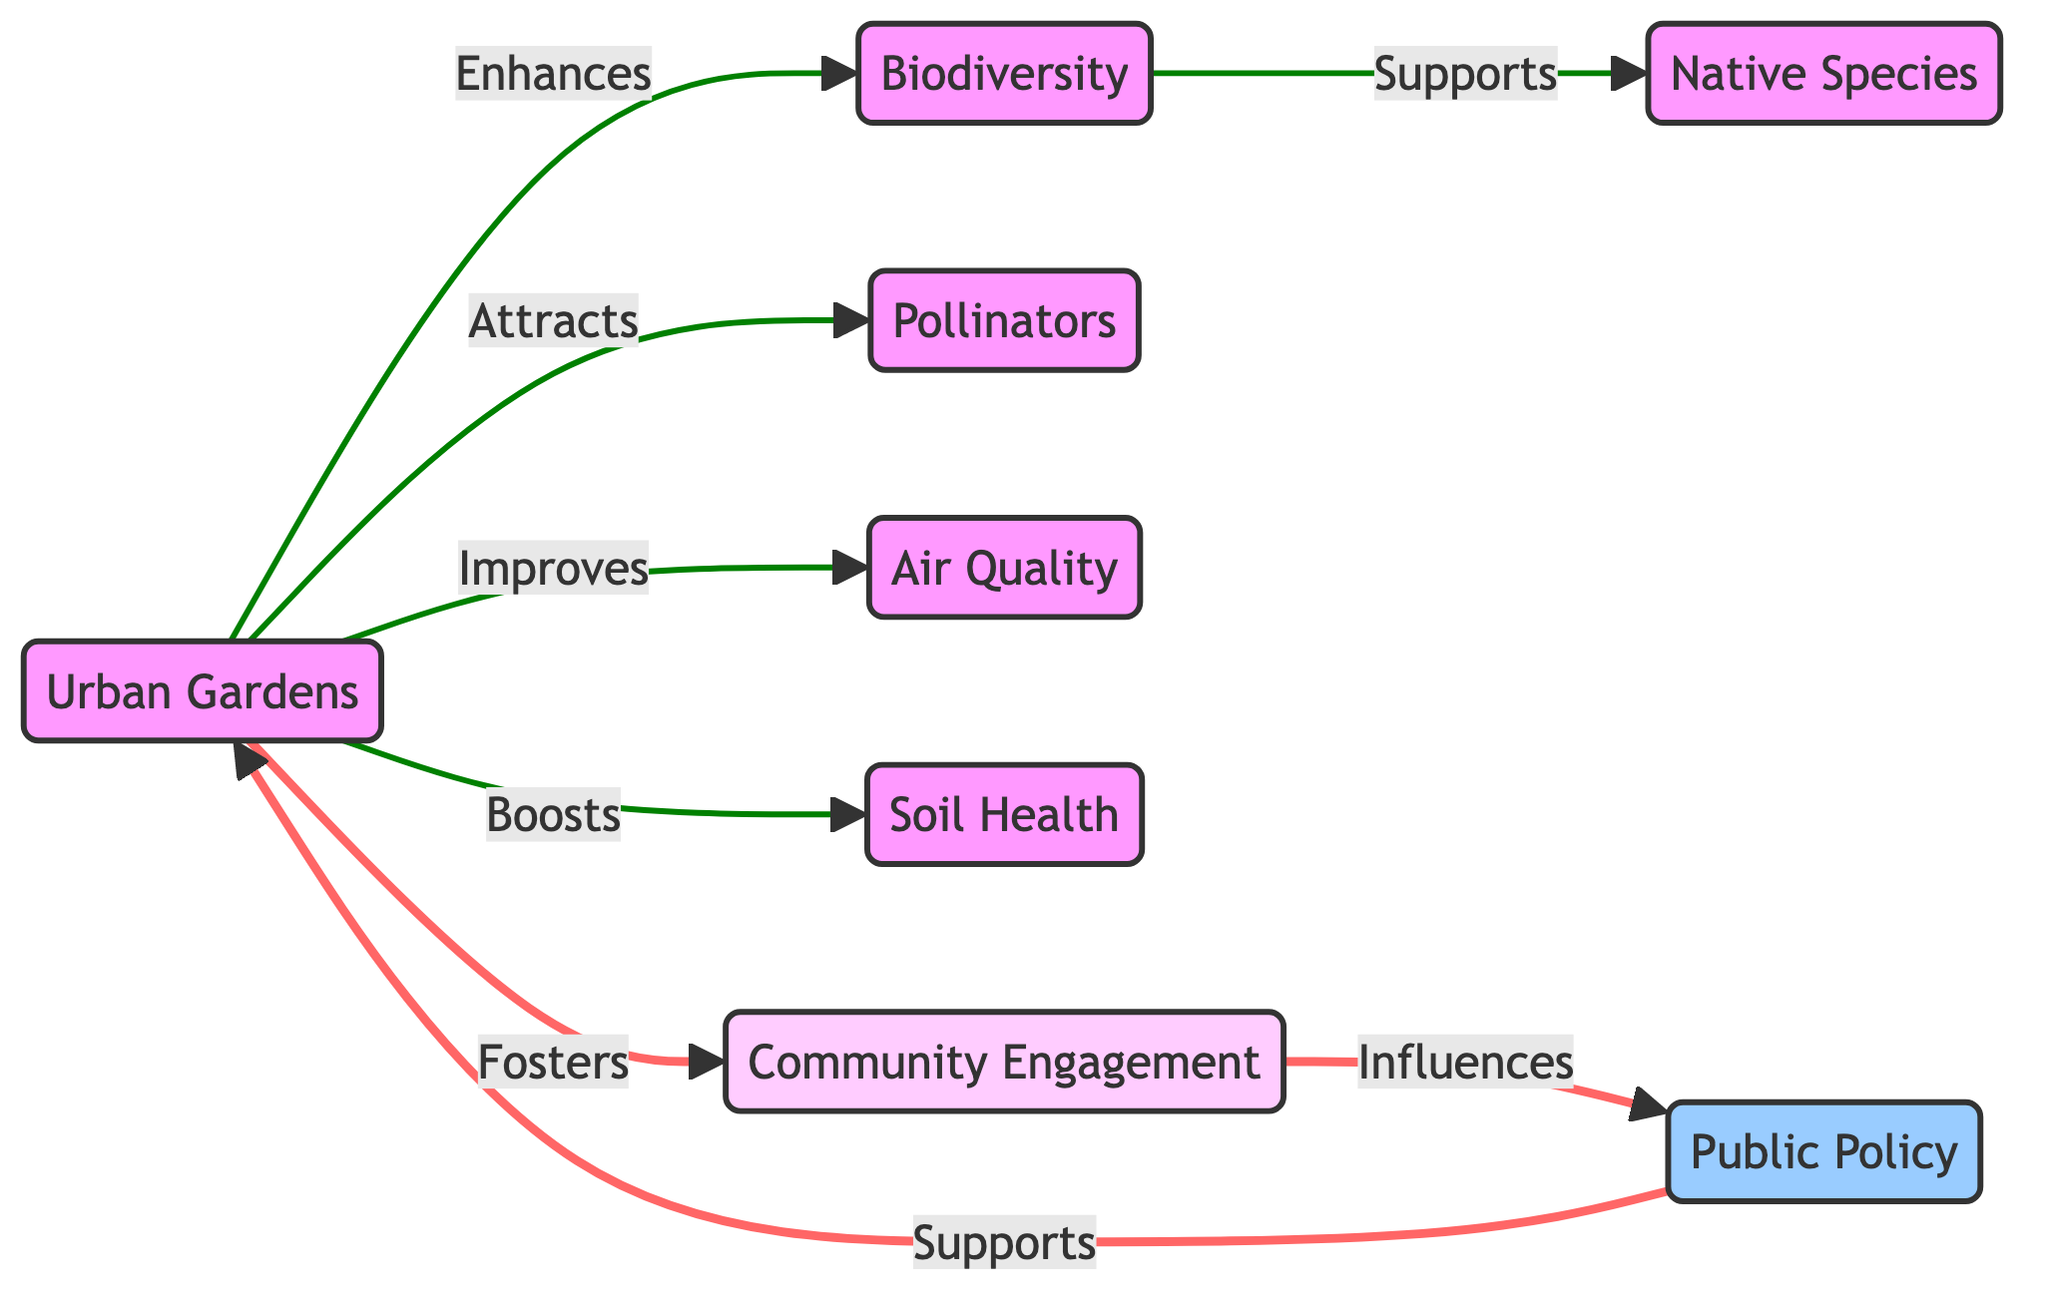What is the main contribution of urban gardens? Urban gardens enhance biodiversity, as directly stated in the diagram through the connection labeled "Enhances." This implies that urban gardens have a positive effect on the variety of life forms in the ecosystem.
Answer: Biodiversity How many direct benefits do urban gardens provide as indicated in the diagram? The diagram shows six direct benefits of urban gardens, with connections leading to biodiversity, pollinators, air quality, soil health, and community engagement. Each of these nodes represents a specific benefit.
Answer: Six What does biodiversity support according to the diagram? The diagram indicates that biodiversity supports native species, shown through the connection labeled "Supports." This means that a greater diversity of life contributes positively to the existence and proliferation of native species in urban gardens.
Answer: Native Species Which element influences public policy in the diagram? The diagram illustrates that community engagement influences public policy, as indicated by the connection labeled "Influences." This suggests that when communities are actively engaged in urban gardening, this involvement can impact the formulation of public policies regarding these spaces.
Answer: Community Engagement What does urban gardens improve that relates to environmental quality? The diagram states that urban gardens improve air quality, which is explicitly shown through the connection labeled "Improves." This demonstrates the role of urban gardens in enhancing the cleanliness and quality of air in urban ecosystems.
Answer: Air Quality Which element supports urban gardens as per the diagram’s connections? The diagram indicates that public policy supports urban gardens, as shown through the connection labeled "Supports." This means that favorable policies can create an environment conducive to the development and maintenance of urban gardens.
Answer: Public Policy What role do urban gardens play in attracting specific species? Urban gardens attract pollinators, as noted in the diagram under the connection labeled "Attracts." This highlights the importance of urban gardens not only for human enjoyment but also for attracting species crucial for plant reproduction.
Answer: Pollinators How many nodes are connected directly to urban gardens? The diagram has five nodes directly connected to urban gardens, namely biodiversity, pollinators, air quality, soil health, and community engagement. Each of these nodes indicates a benefit or role that urban gardens provide.
Answer: Five 